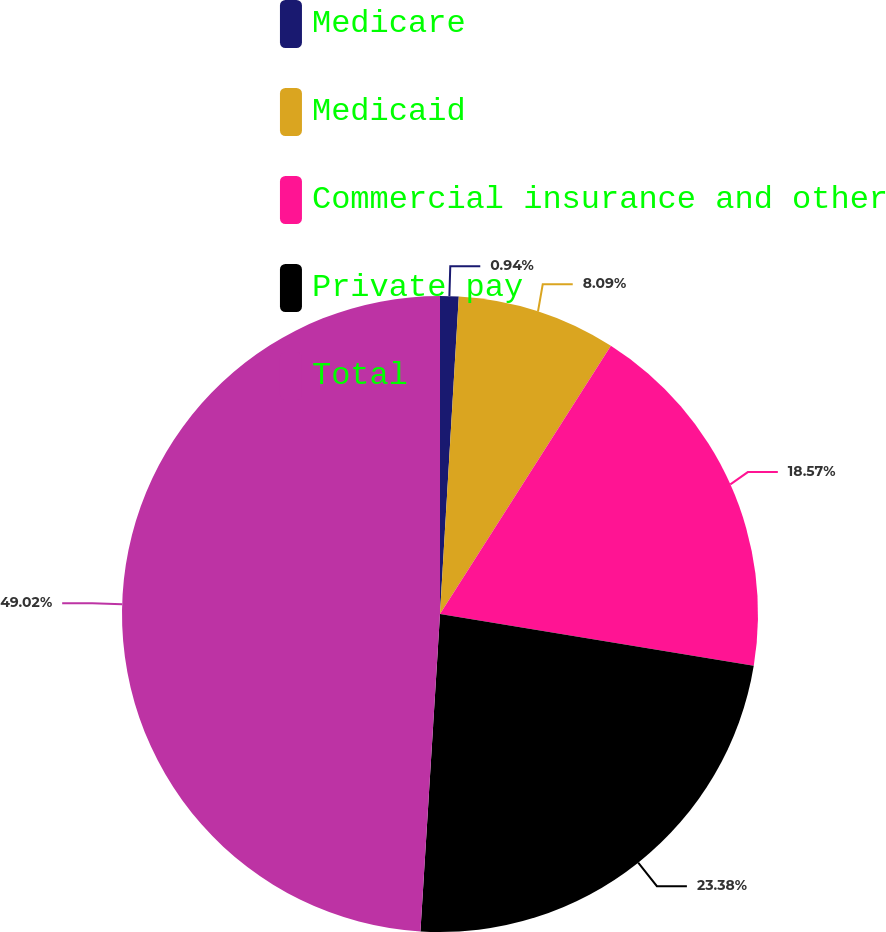Convert chart. <chart><loc_0><loc_0><loc_500><loc_500><pie_chart><fcel>Medicare<fcel>Medicaid<fcel>Commercial insurance and other<fcel>Private pay<fcel>Total<nl><fcel>0.94%<fcel>8.09%<fcel>18.57%<fcel>23.38%<fcel>49.02%<nl></chart> 